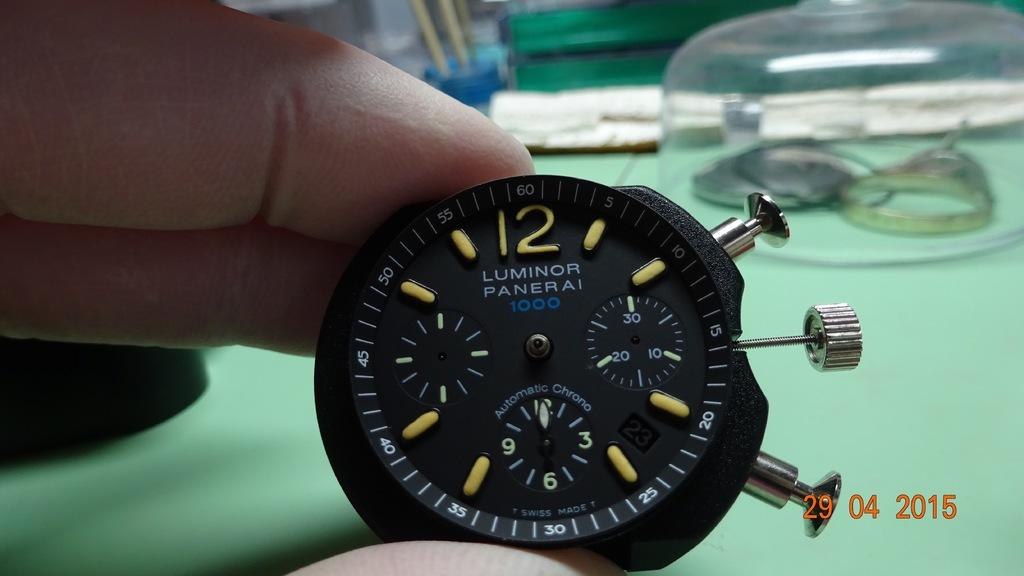<image>
Render a clear and concise summary of the photo. A person holds a black Luminor Panerai 1000 in front of a green surface. 